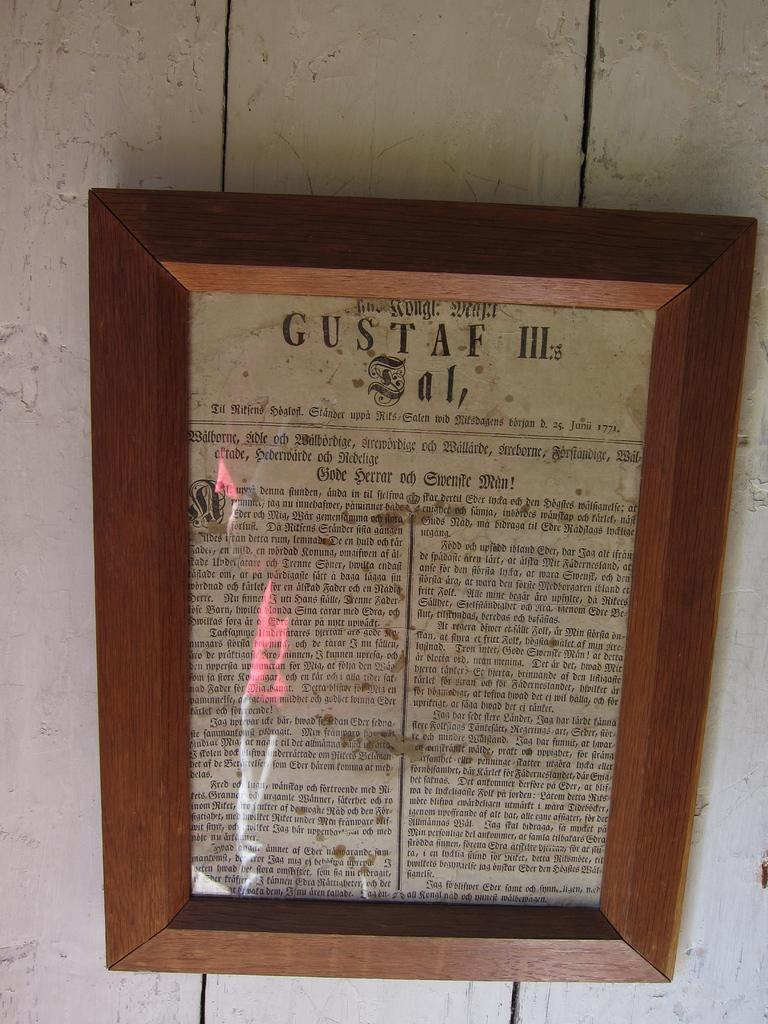<image>
Present a compact description of the photo's key features. An old newspaper headline reads Gustaf III at the top. 